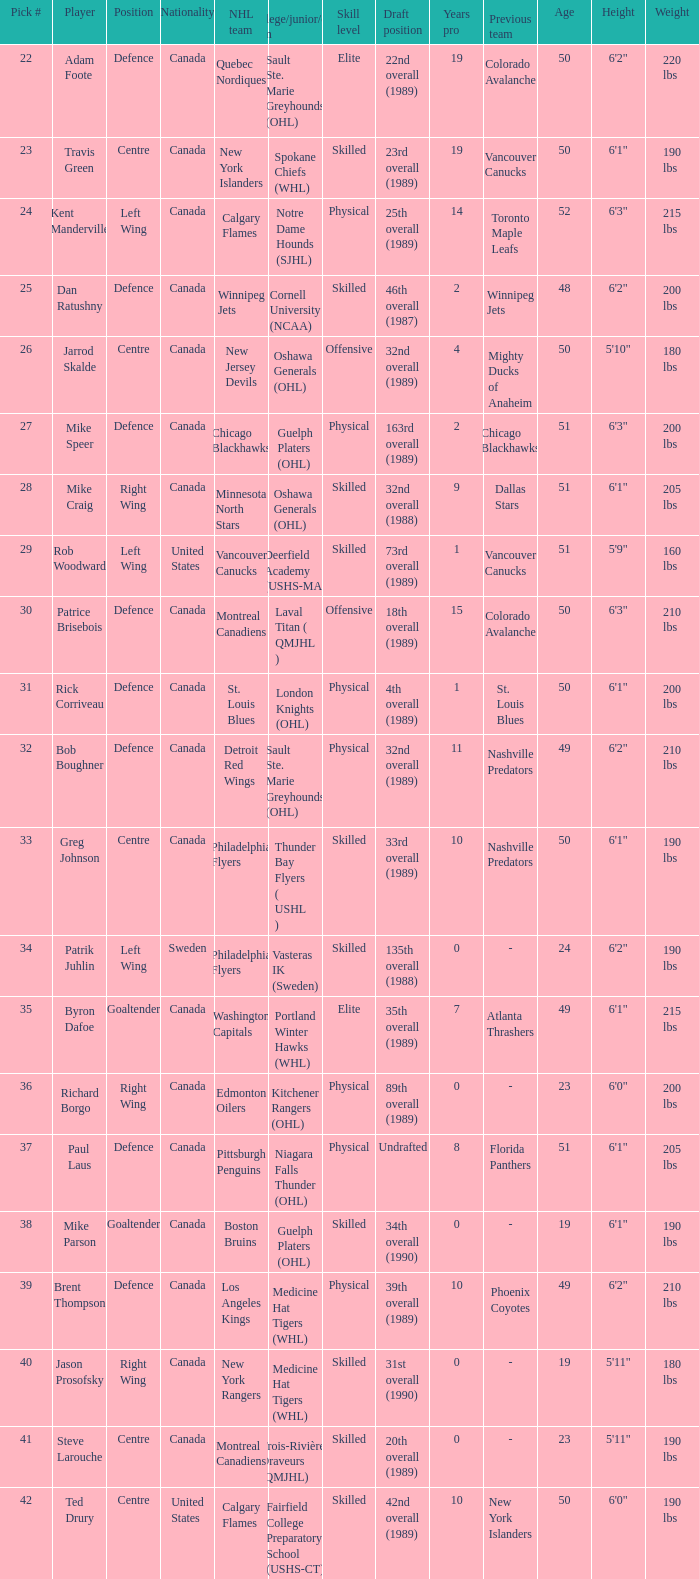How many draft selections is athlete byron dafoe? 1.0. 